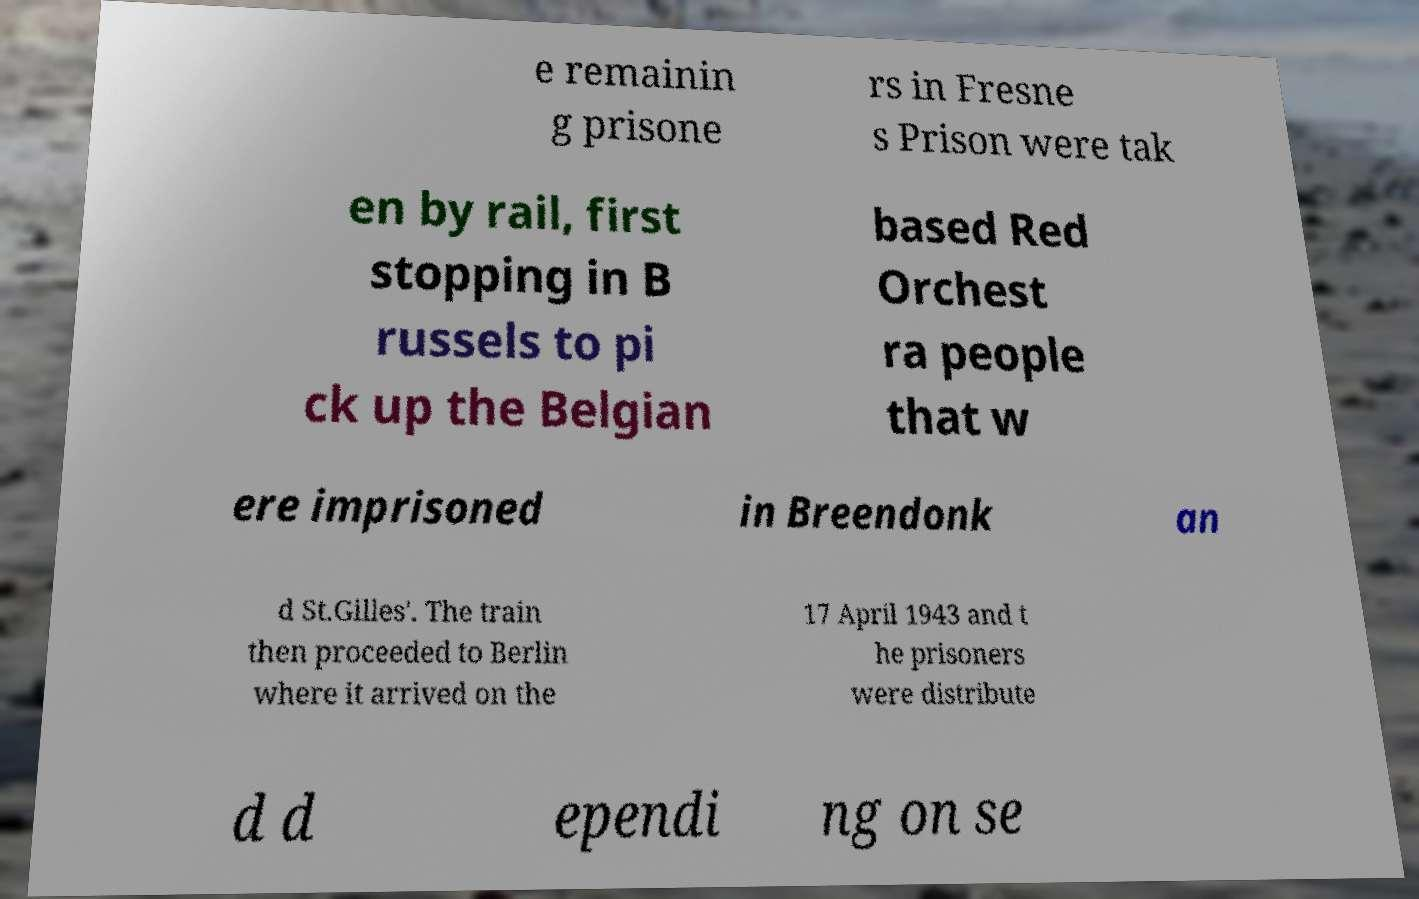Please read and relay the text visible in this image. What does it say? e remainin g prisone rs in Fresne s Prison were tak en by rail, first stopping in B russels to pi ck up the Belgian based Red Orchest ra people that w ere imprisoned in Breendonk an d St.Gilles'. The train then proceeded to Berlin where it arrived on the 17 April 1943 and t he prisoners were distribute d d ependi ng on se 